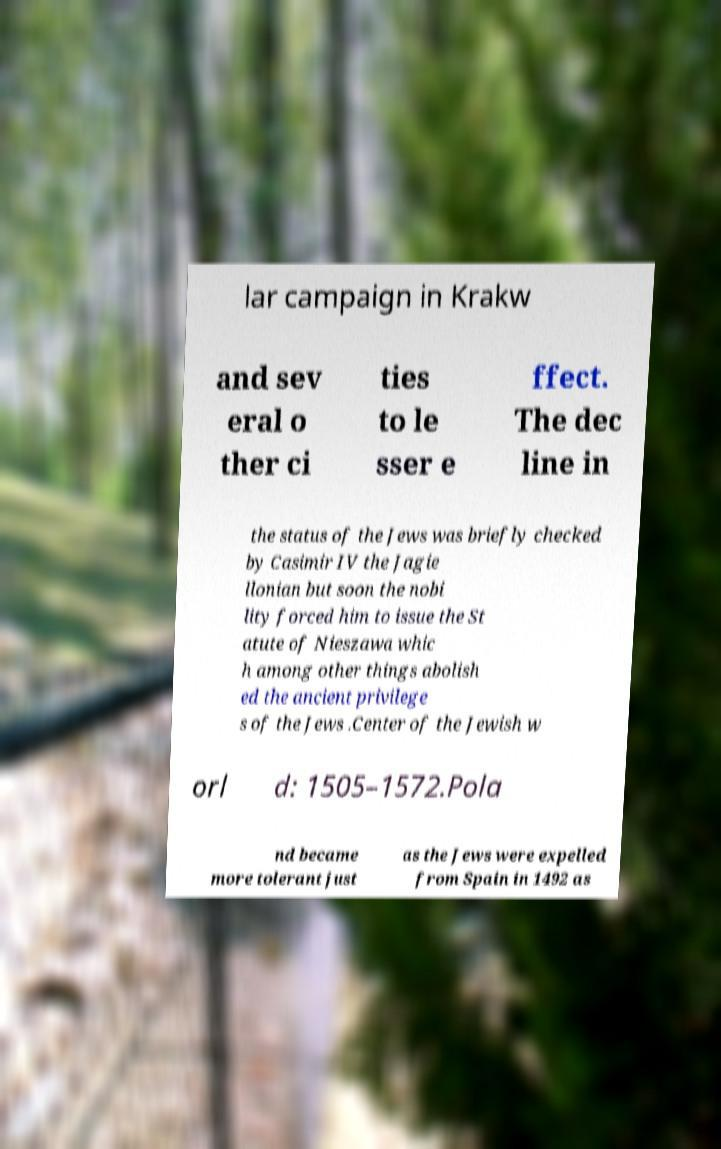Please identify and transcribe the text found in this image. lar campaign in Krakw and sev eral o ther ci ties to le sser e ffect. The dec line in the status of the Jews was briefly checked by Casimir IV the Jagie llonian but soon the nobi lity forced him to issue the St atute of Nieszawa whic h among other things abolish ed the ancient privilege s of the Jews .Center of the Jewish w orl d: 1505–1572.Pola nd became more tolerant just as the Jews were expelled from Spain in 1492 as 